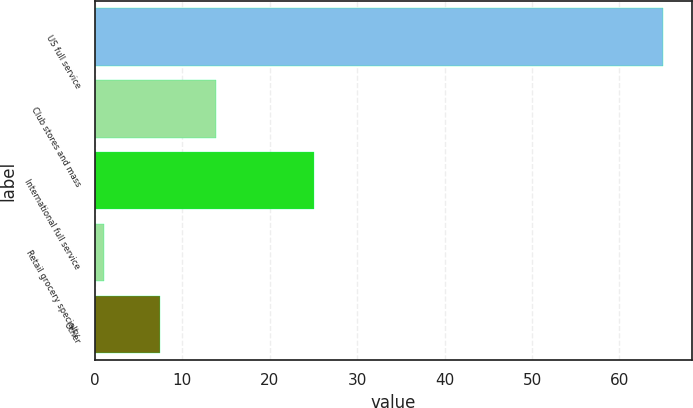Convert chart to OTSL. <chart><loc_0><loc_0><loc_500><loc_500><bar_chart><fcel>US full service<fcel>Club stores and mass<fcel>International full service<fcel>Retail grocery specialty<fcel>Other<nl><fcel>65<fcel>13.8<fcel>25<fcel>1<fcel>7.4<nl></chart> 